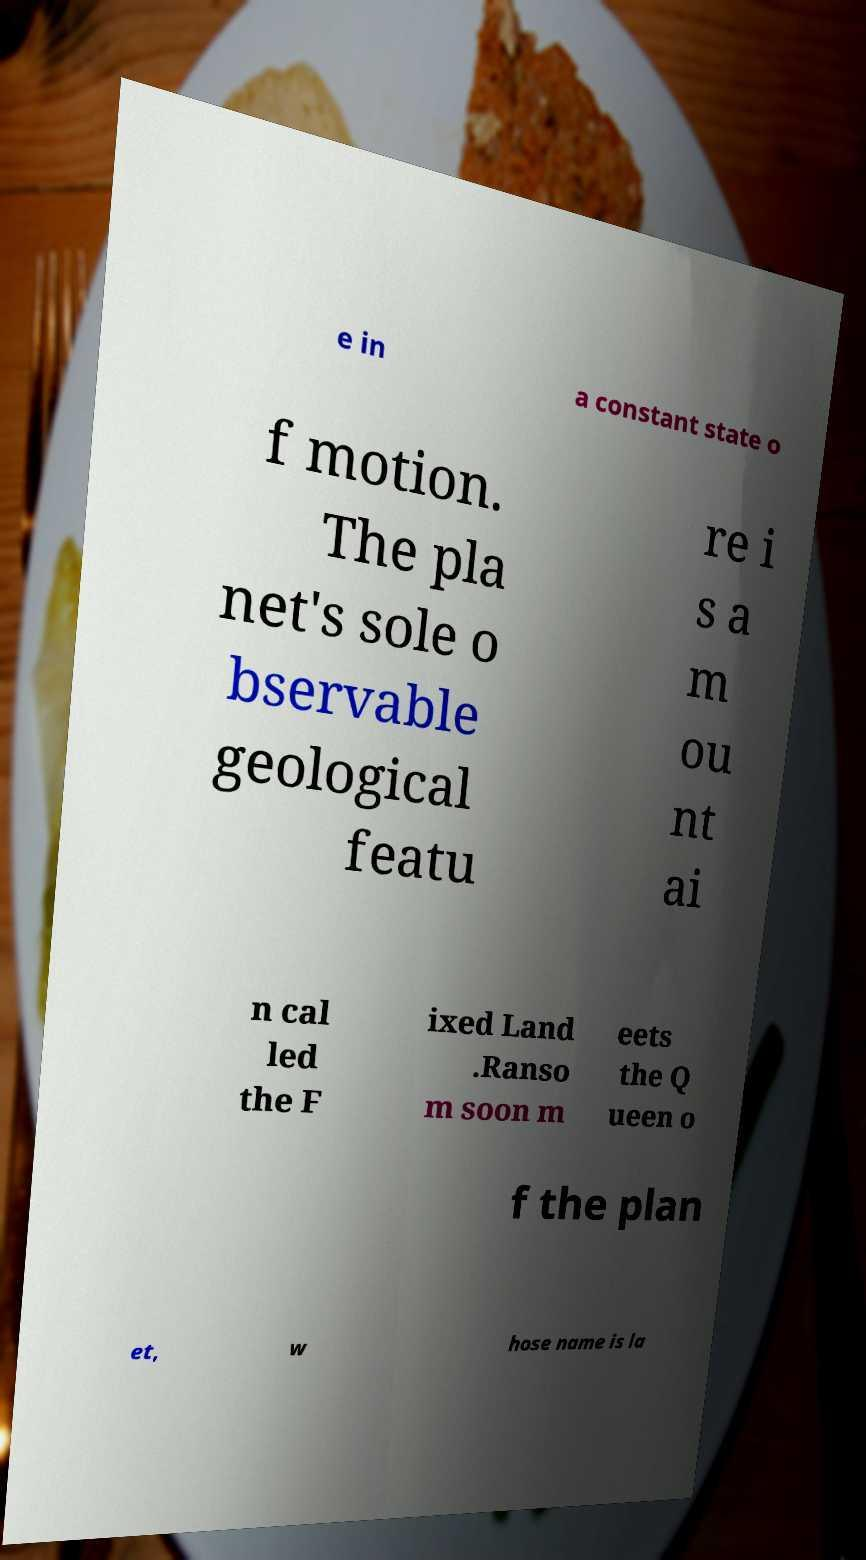For documentation purposes, I need the text within this image transcribed. Could you provide that? e in a constant state o f motion. The pla net's sole o bservable geological featu re i s a m ou nt ai n cal led the F ixed Land .Ranso m soon m eets the Q ueen o f the plan et, w hose name is la 